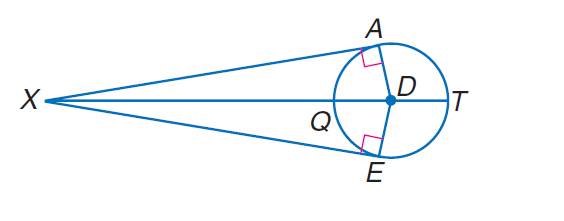Answer the mathemtical geometry problem and directly provide the correct option letter.
Question: Find D X if E X = 24 and D E = 7.
Choices: A: 1 B: 7 C: 24 D: 25 D 